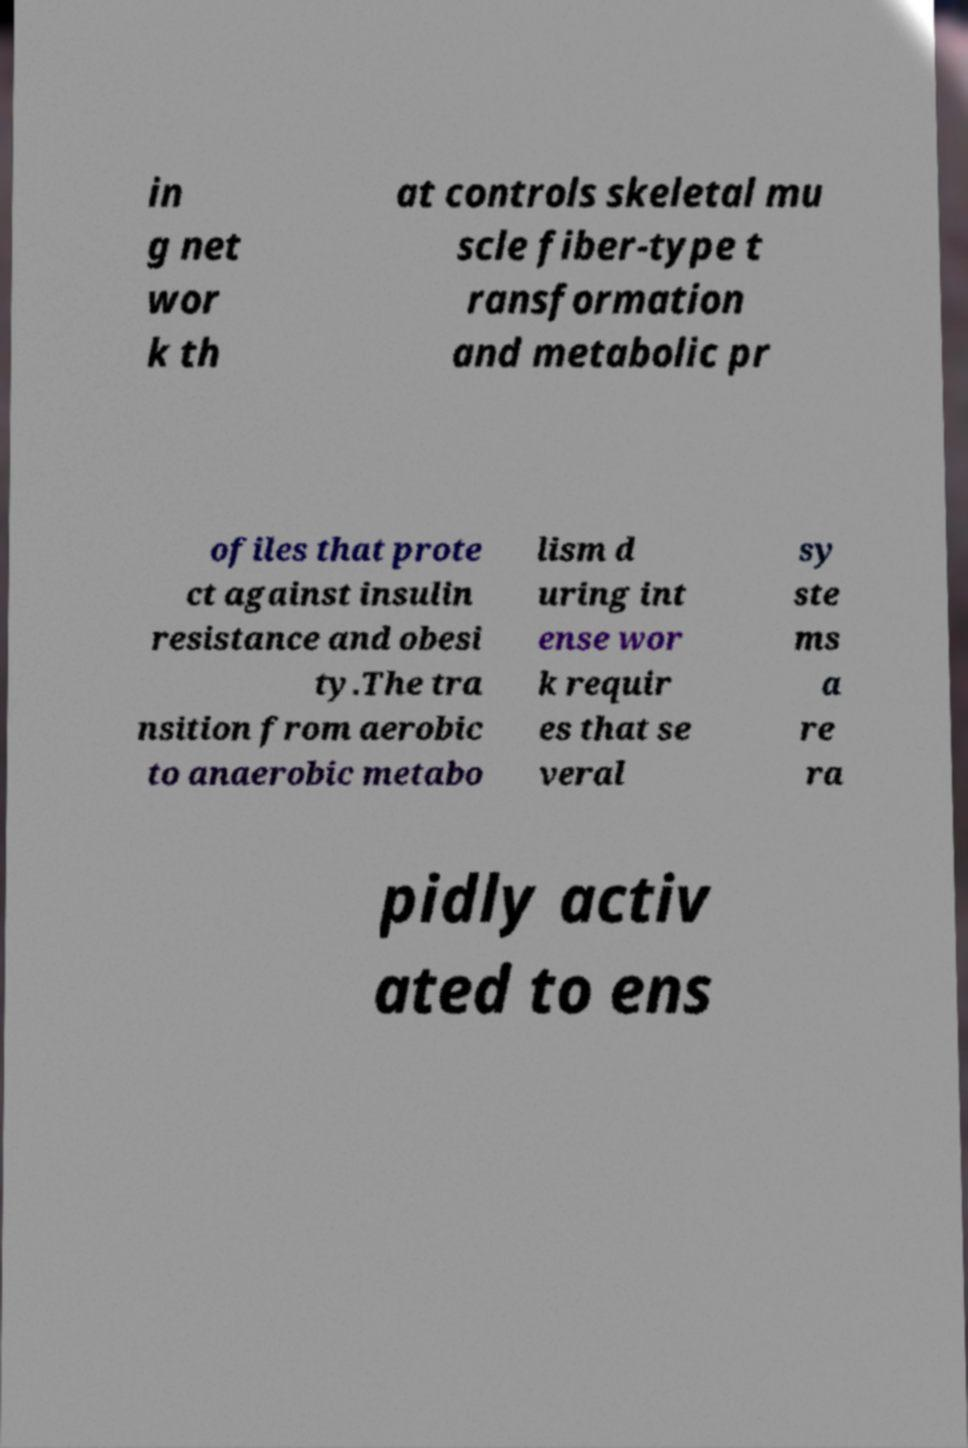There's text embedded in this image that I need extracted. Can you transcribe it verbatim? in g net wor k th at controls skeletal mu scle fiber-type t ransformation and metabolic pr ofiles that prote ct against insulin resistance and obesi ty.The tra nsition from aerobic to anaerobic metabo lism d uring int ense wor k requir es that se veral sy ste ms a re ra pidly activ ated to ens 